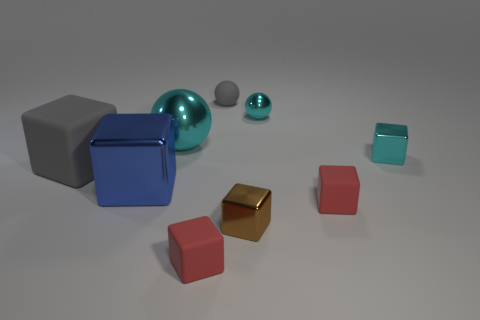Subtract all cyan cubes. How many cubes are left? 5 Subtract all cyan balls. How many balls are left? 1 Add 1 gray objects. How many objects exist? 10 Subtract 1 brown blocks. How many objects are left? 8 Subtract all blocks. How many objects are left? 3 Subtract 1 balls. How many balls are left? 2 Subtract all yellow spheres. Subtract all yellow cubes. How many spheres are left? 3 Subtract all brown balls. How many purple cubes are left? 0 Subtract all gray metallic cylinders. Subtract all brown things. How many objects are left? 8 Add 1 tiny gray things. How many tiny gray things are left? 2 